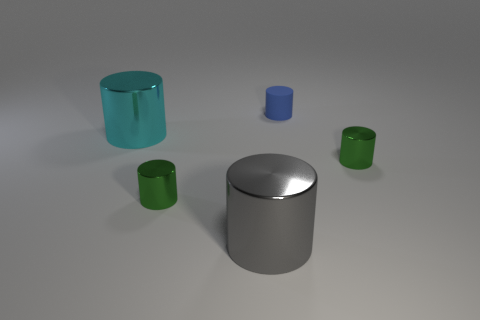There is another large object that is the same shape as the gray metallic thing; what is it made of?
Provide a succinct answer. Metal. Are there more tiny green metallic objects that are behind the big cyan cylinder than blue objects left of the large gray thing?
Your response must be concise. No. There is a tiny rubber object; does it have the same color as the tiny shiny thing left of the blue rubber thing?
Your answer should be compact. No. What material is the cylinder that is the same size as the cyan thing?
Make the answer very short. Metal. What number of objects are either objects or large metal cylinders that are left of the big gray shiny cylinder?
Offer a very short reply. 5. There is a rubber object; is its size the same as the cyan shiny thing in front of the rubber thing?
Provide a succinct answer. No. How many balls are either cyan shiny things or green things?
Your answer should be very brief. 0. What number of cylinders are both in front of the small blue thing and right of the big cyan cylinder?
Your answer should be very brief. 3. How many other things are the same color as the tiny rubber cylinder?
Provide a succinct answer. 0. What is the shape of the small green metallic thing to the left of the blue object?
Your response must be concise. Cylinder. 